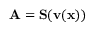Convert formula to latex. <formula><loc_0><loc_0><loc_500><loc_500>A = S ( v ( x ) )</formula> 